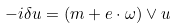Convert formula to latex. <formula><loc_0><loc_0><loc_500><loc_500>- i \delta u = ( m + e \cdot \omega ) \vee u</formula> 